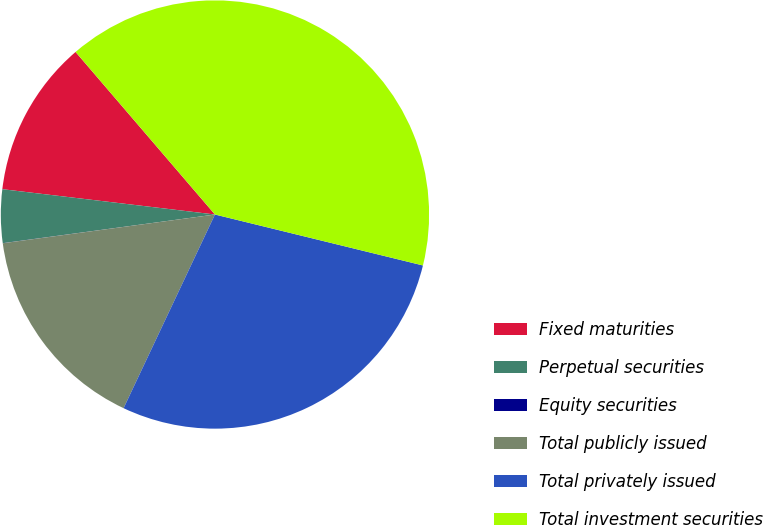Convert chart. <chart><loc_0><loc_0><loc_500><loc_500><pie_chart><fcel>Fixed maturities<fcel>Perpetual securities<fcel>Equity securities<fcel>Total publicly issued<fcel>Total privately issued<fcel>Total investment securities<nl><fcel>11.83%<fcel>4.02%<fcel>0.01%<fcel>15.84%<fcel>28.19%<fcel>40.1%<nl></chart> 